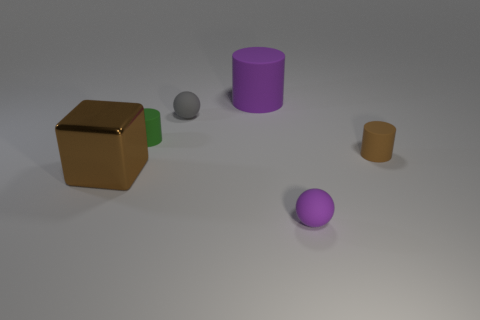How many brown objects are small cubes or large blocks?
Provide a short and direct response. 1. What shape is the brown object that is the same size as the gray rubber thing?
Offer a very short reply. Cylinder. How many other objects are there of the same color as the large cylinder?
Give a very brief answer. 1. There is a sphere left of the purple matte object that is right of the large purple rubber cylinder; what is its size?
Your response must be concise. Small. Are the ball that is behind the cube and the brown cylinder made of the same material?
Your response must be concise. Yes. What is the shape of the brown thing that is left of the tiny gray rubber object?
Keep it short and to the point. Cube. What number of other purple matte cylinders have the same size as the purple cylinder?
Offer a terse response. 0. The green cylinder has what size?
Make the answer very short. Small. There is a brown matte object; how many large cylinders are to the left of it?
Offer a terse response. 1. What shape is the green object that is made of the same material as the large purple thing?
Make the answer very short. Cylinder. 